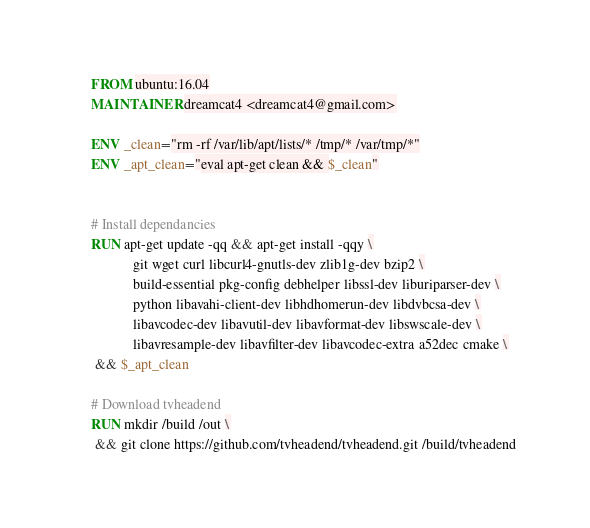<code> <loc_0><loc_0><loc_500><loc_500><_Dockerfile_>FROM ubuntu:16.04
MAINTAINER dreamcat4 <dreamcat4@gmail.com>

ENV _clean="rm -rf /var/lib/apt/lists/* /tmp/* /var/tmp/*"
ENV _apt_clean="eval apt-get clean && $_clean"


# Install dependancies
RUN apt-get update -qq && apt-get install -qqy \
			git wget curl libcurl4-gnutls-dev zlib1g-dev bzip2 \
			build-essential pkg-config debhelper libssl-dev liburiparser-dev \
			python libavahi-client-dev libhdhomerun-dev libdvbcsa-dev \
			libavcodec-dev libavutil-dev libavformat-dev libswscale-dev \
			libavresample-dev libavfilter-dev libavcodec-extra a52dec cmake \
 && $_apt_clean

# Download tvheadend
RUN mkdir /build /out \
 && git clone https://github.com/tvheadend/tvheadend.git /build/tvheadend


</code> 